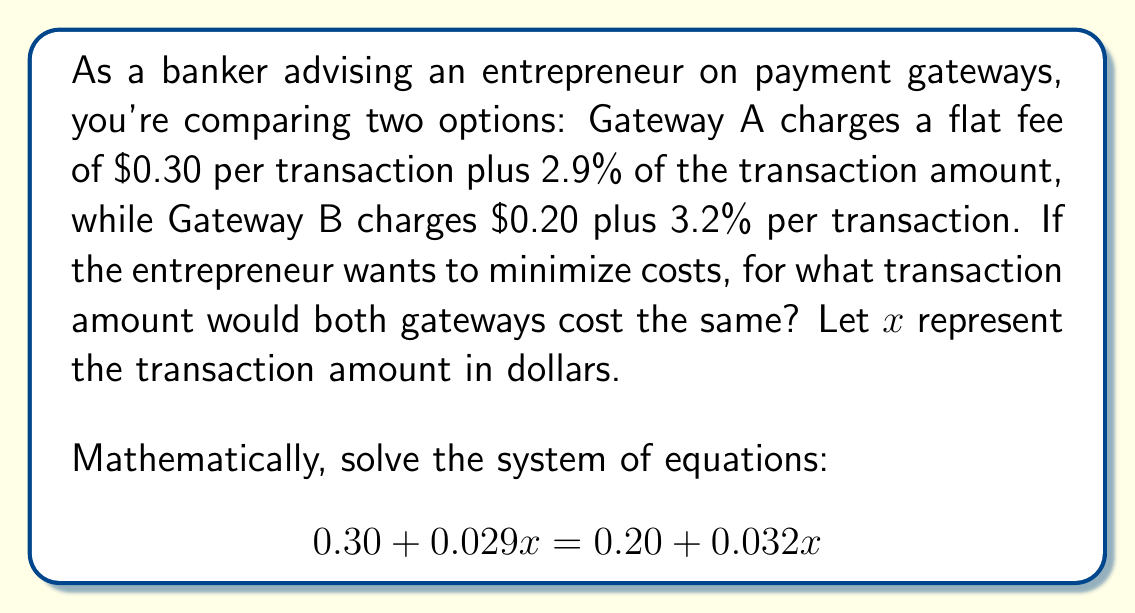Can you answer this question? Let's solve this step-by-step:

1) We start with the equation:
   $$0.30 + 0.029x = 0.20 + 0.032x$$

2) Subtract 0.20 from both sides:
   $$0.10 + 0.029x = 0.032x$$

3) Subtract 0.029x from both sides:
   $$0.10 = 0.032x - 0.029x$$

4) Simplify the right side:
   $$0.10 = 0.003x$$

5) Divide both sides by 0.003:
   $$\frac{0.10}{0.003} = x$$

6) Simplify:
   $$33.33 = x$$

Therefore, at a transaction amount of $33.33, both gateways would charge the same fee.

To verify:
- Gateway A: $0.30 + (0.029 * 33.33) = 0.30 + 0.97 = 1.27$
- Gateway B: $0.20 + (0.032 * 33.33) = 0.20 + 1.07 = 1.27$

Both gateways charge $1.27 for a $33.33 transaction.
Answer: $33.33 